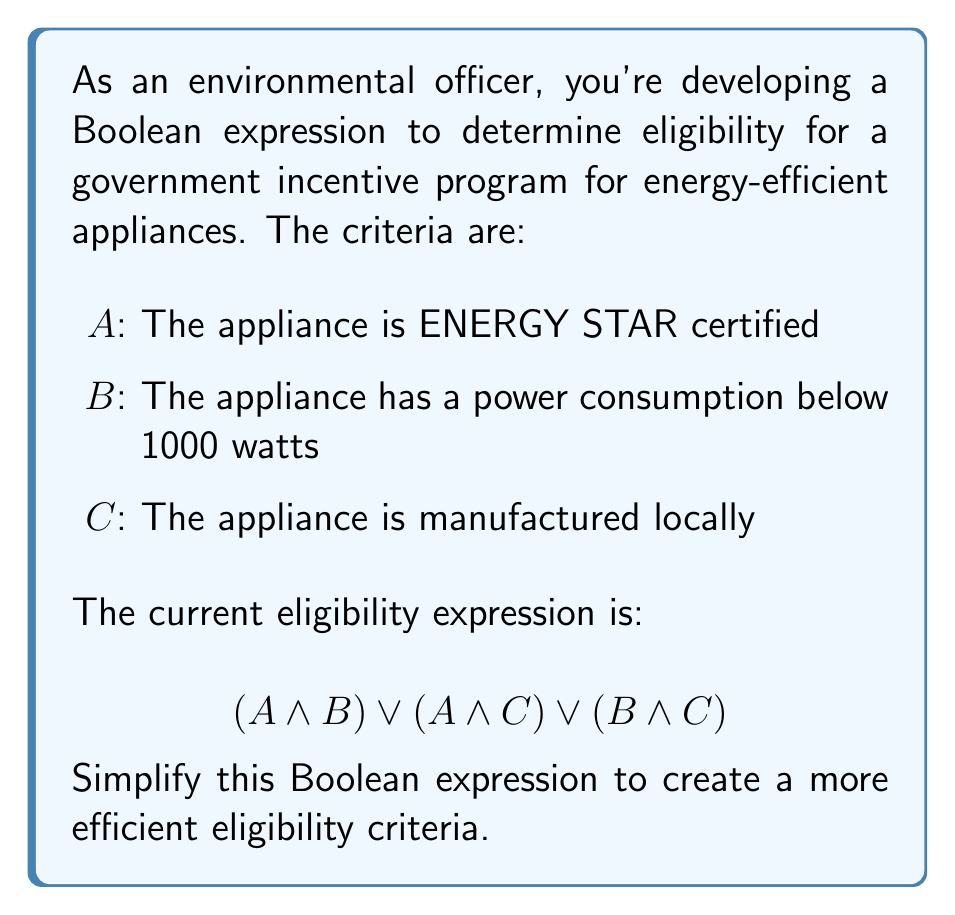Solve this math problem. Let's simplify this Boolean expression step by step:

1) First, we can apply the distributive law to factor out the common term:
   $$(A \land B) \lor (A \land C) \lor (B \land C)$$
   $$= A \land (B \lor C) \lor (B \land C)$$

2) Now, we can apply one of the absorption laws. The absorption law states that $X \lor (X \land Y) = X$. In this case, let $X = (B \lor C)$ and $Y = A$:
   $$A \land (B \lor C) \lor (B \land C)$$
   $$= (B \lor C) \lor (A \land (B \lor C))$$

3) Applying the absorption law:
   $$= B \lor C$$

Therefore, the simplified Boolean expression for the eligibility criteria is $B \lor C$.

This means that an appliance is eligible for the incentive if it either has a power consumption below 1000 watts OR is manufactured locally, regardless of its ENERGY STAR certification.
Answer: $$B \lor C$$ 